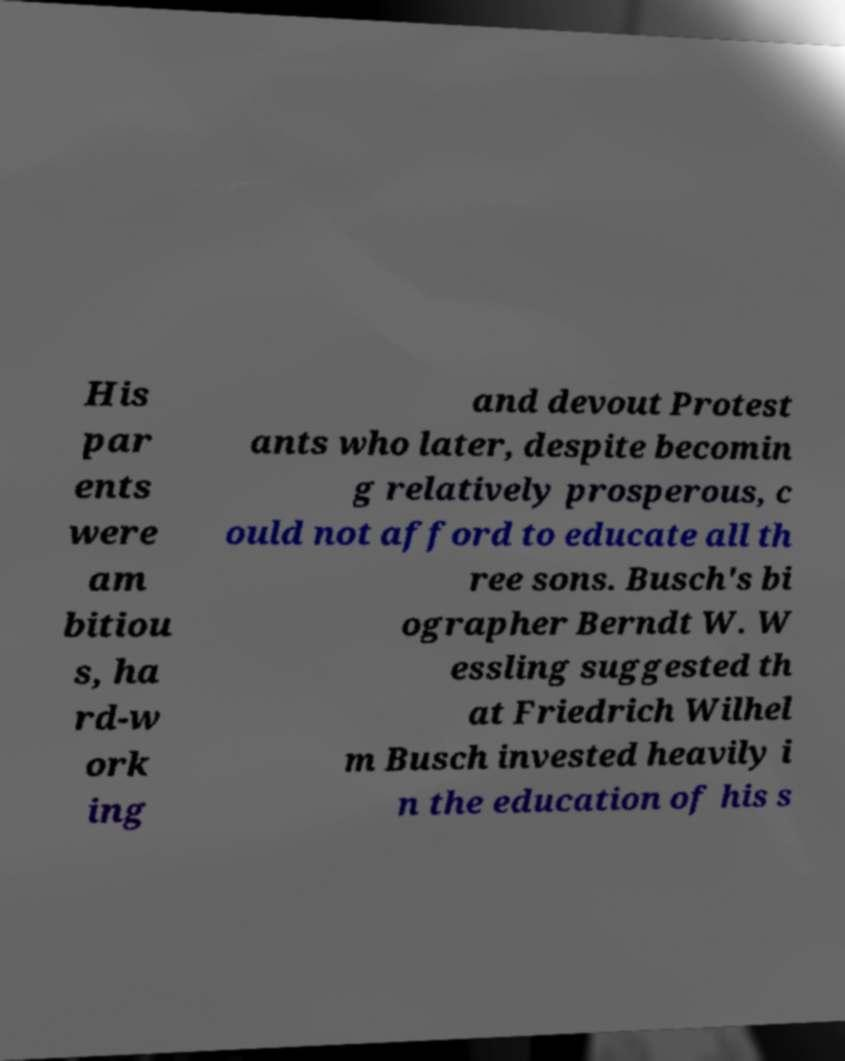Could you extract and type out the text from this image? His par ents were am bitiou s, ha rd-w ork ing and devout Protest ants who later, despite becomin g relatively prosperous, c ould not afford to educate all th ree sons. Busch's bi ographer Berndt W. W essling suggested th at Friedrich Wilhel m Busch invested heavily i n the education of his s 